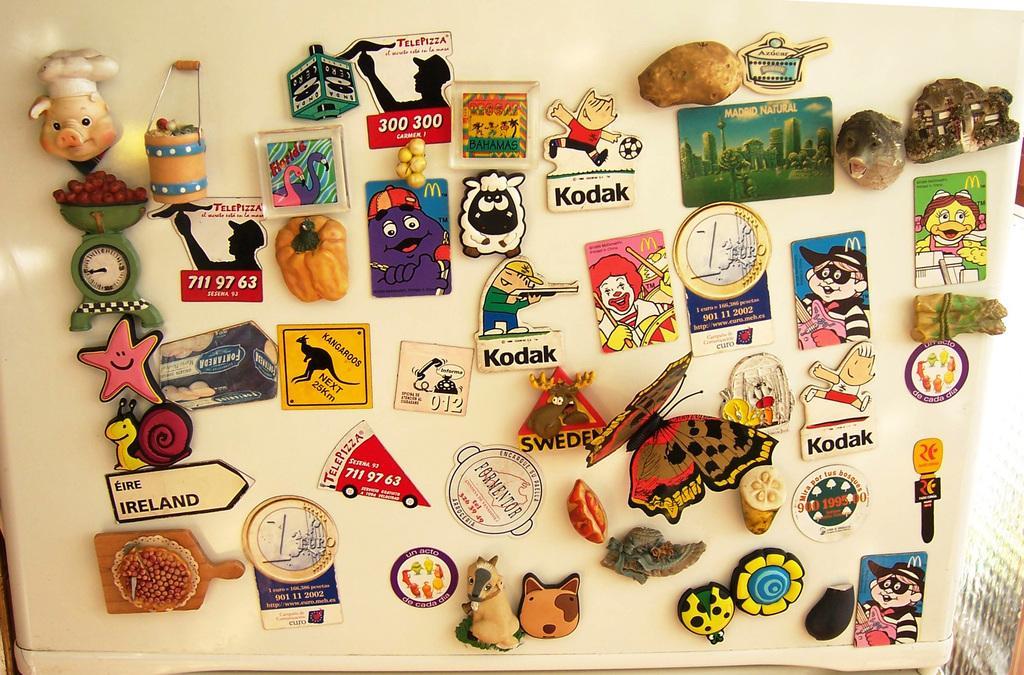Can you describe this image briefly? In this picture there are stickers in the center of the image, which includes animals and vegetables in it. 